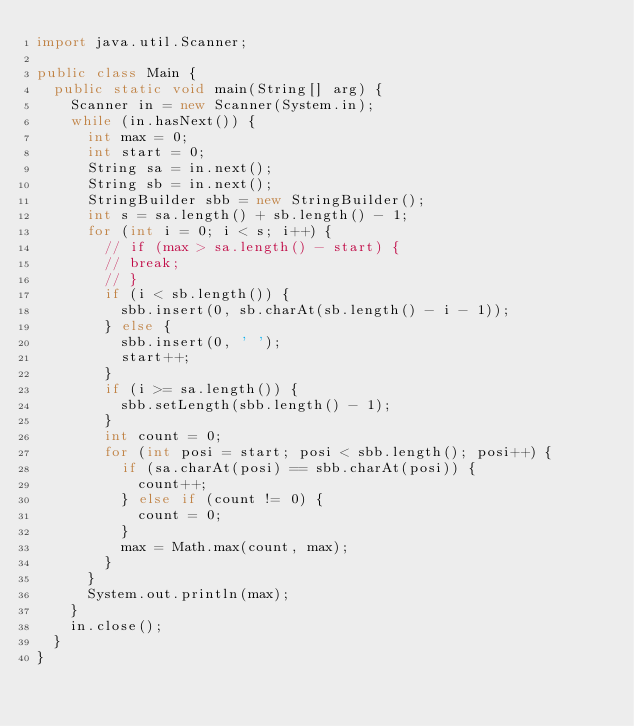<code> <loc_0><loc_0><loc_500><loc_500><_Java_>import java.util.Scanner;

public class Main {
	public static void main(String[] arg) {
		Scanner in = new Scanner(System.in);
		while (in.hasNext()) {
			int max = 0;
			int start = 0;
			String sa = in.next();
			String sb = in.next();
			StringBuilder sbb = new StringBuilder();
			int s = sa.length() + sb.length() - 1;
			for (int i = 0; i < s; i++) {
				// if (max > sa.length() - start) {
				// break;
				// }
				if (i < sb.length()) {
					sbb.insert(0, sb.charAt(sb.length() - i - 1));
				} else {
					sbb.insert(0, ' ');
					start++;
				}
				if (i >= sa.length()) {
					sbb.setLength(sbb.length() - 1);
				}
				int count = 0;
				for (int posi = start; posi < sbb.length(); posi++) {
					if (sa.charAt(posi) == sbb.charAt(posi)) {
						count++;
					} else if (count != 0) {
						count = 0;
					}
					max = Math.max(count, max);
				}
			}
			System.out.println(max);
		}
		in.close();
	}
}</code> 